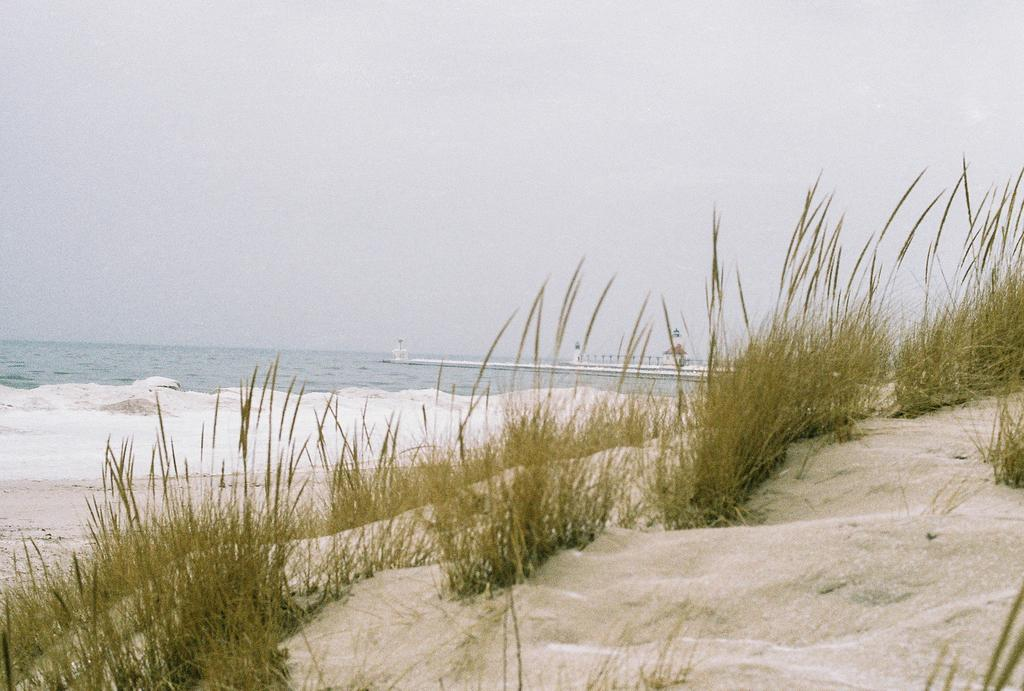What type of vegetation is present in the image? There is grass in the image. What is the grass situated between? The grass is between sand. What can be seen in the distance in the image? There is water visible in the background of the image. Can you describe any other objects or features in the background? There is at least one other object in the background of the image. What type of orange is being advertised on the calendar in the image? There is no orange or calendar present in the image. 